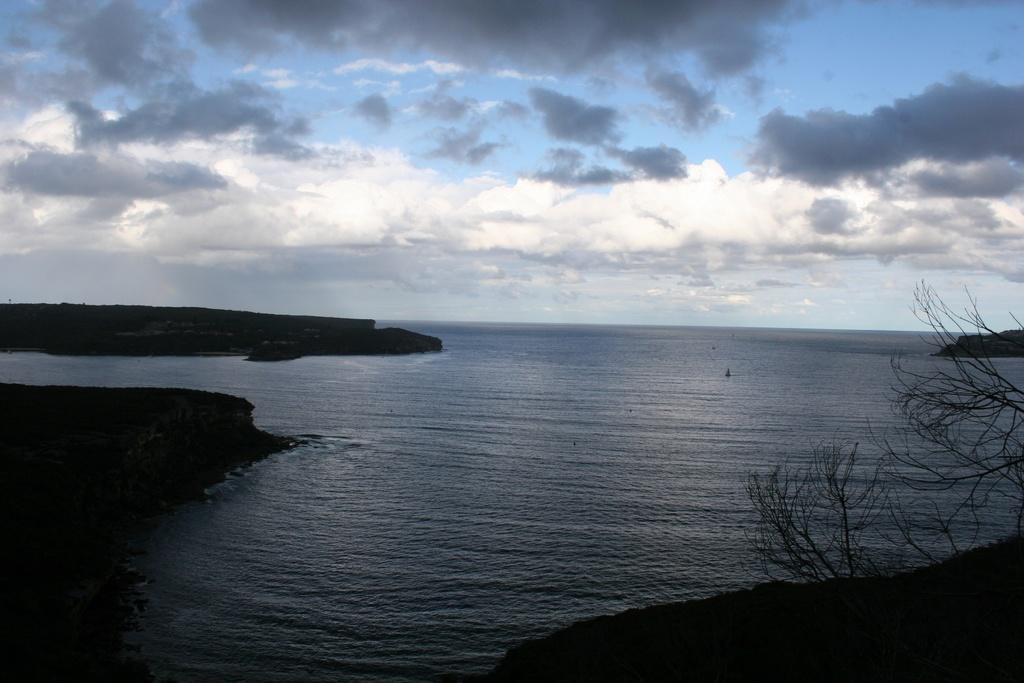What type of plants can be seen in the front of the image? There are dry plants in the front of the image. What is located in the center of the image? There is water in the center of the image. What color are the objects on the left side of the image? The objects on the left side of the image are black in color. How would you describe the sky in the image? The sky is cloudy. What type of behavior does the father exhibit in the image? There is no father present in the image, so it is not possible to comment on his behavior. What is the father using to whip the plants in the image? There is no father or whip present in the image; it features dry plants, water, and black objects. 